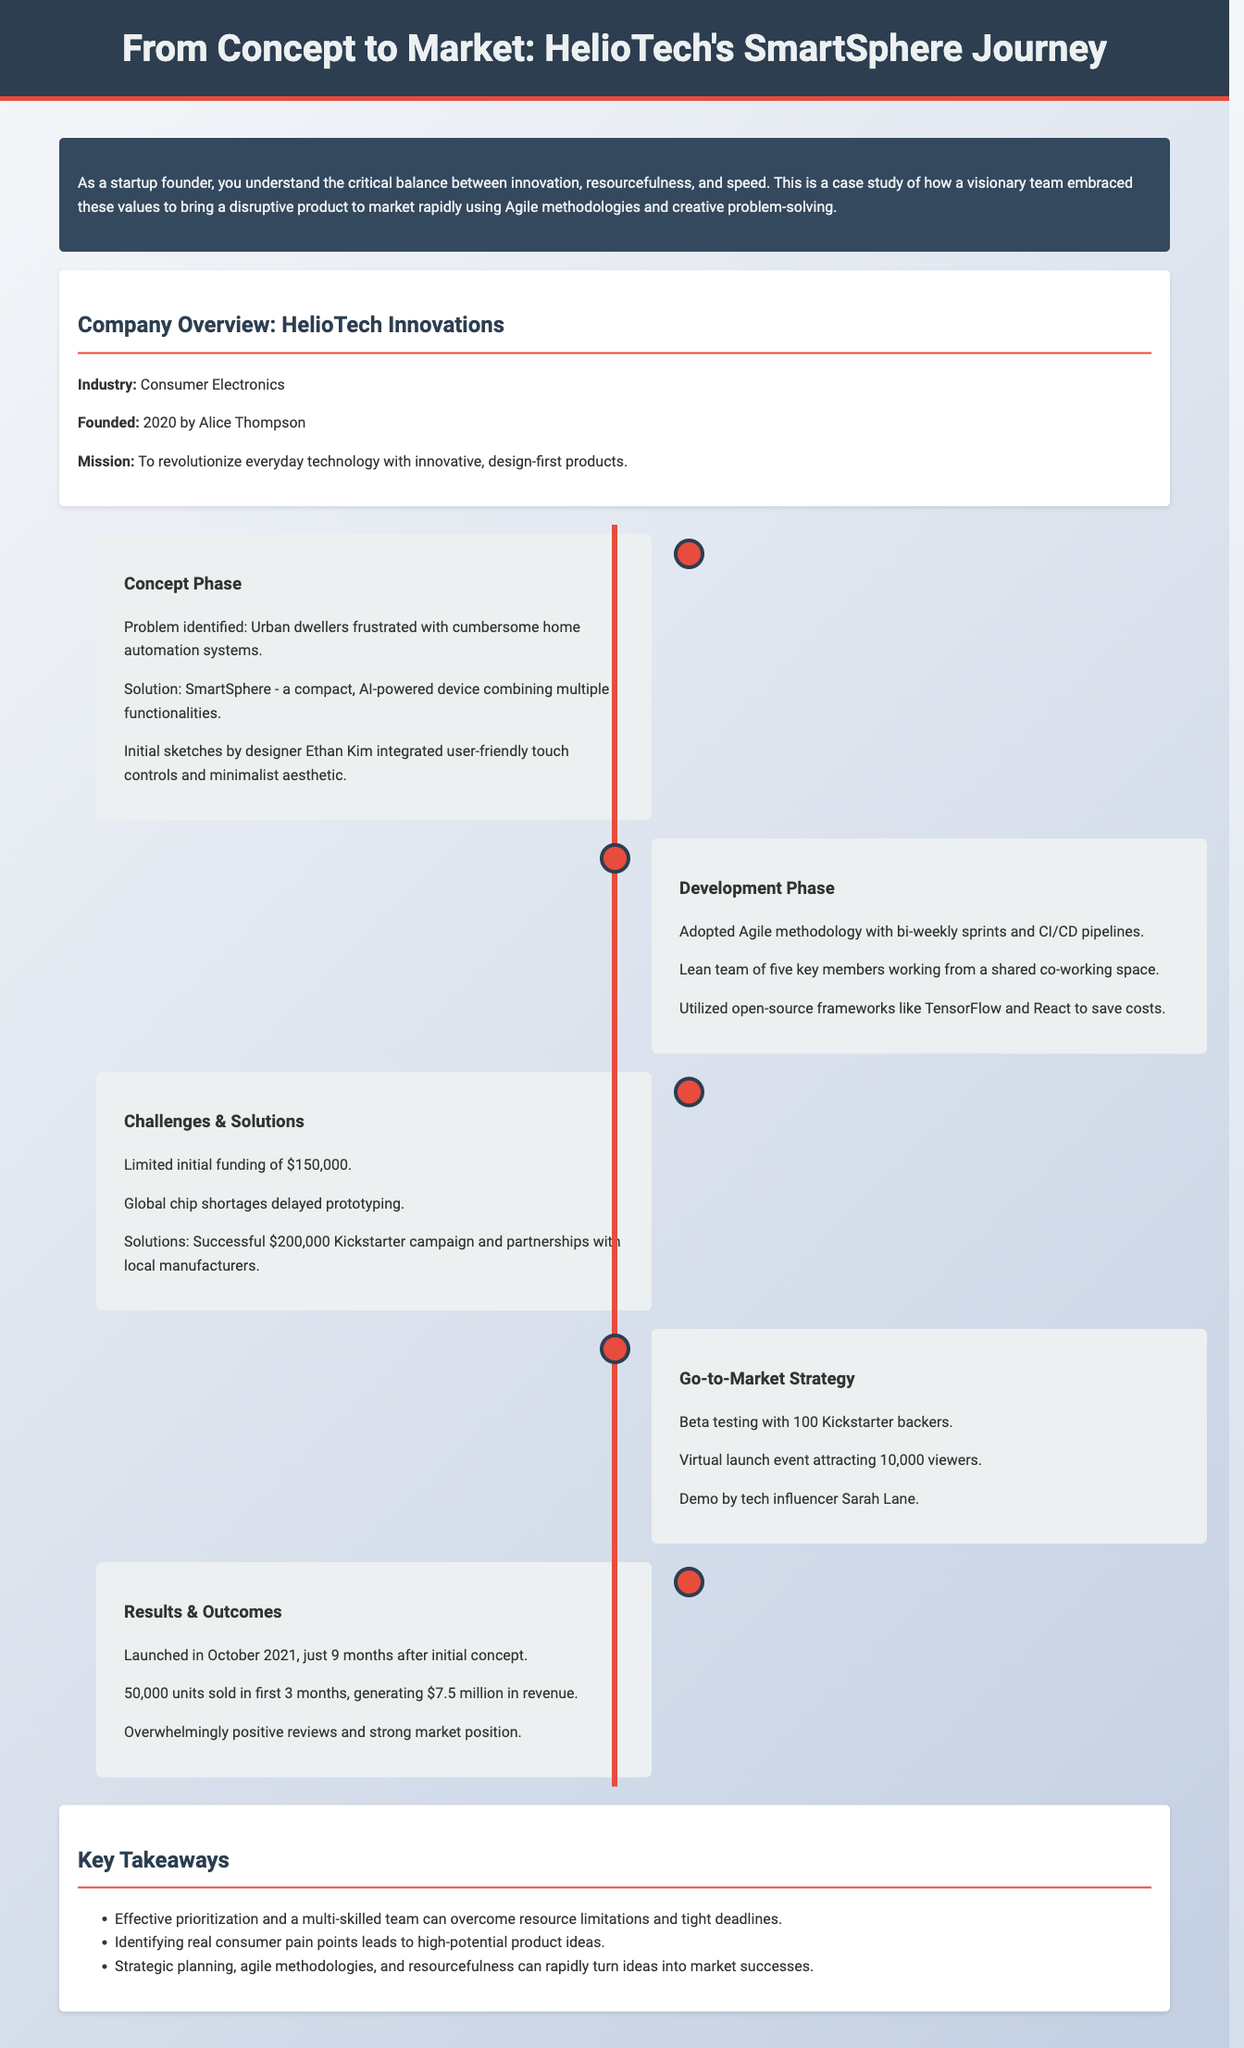what is the name of the company? The company featured in the case study is HelioTech Innovations.
Answer: HelioTech Innovations who founded HelioTech? The founder of HelioTech Innovations is Alice Thompson.
Answer: Alice Thompson what product did HelioTech launch? The product launched by HelioTech is SmartSphere.
Answer: SmartSphere how long did it take to launch SmartSphere? The product was launched just 9 months after the initial concept phase.
Answer: 9 months what was the initial funding amount? The initial funding for the project was $150,000.
Answer: $150,000 how many units were sold in the first 3 months? The total units sold within the first three months after launch were 50,000.
Answer: 50,000 what revenue was generated in the first 3 months? The revenue generated in the first three months was $7.5 million.
Answer: $7.5 million how many Kickstarter backers participated in beta testing? The beta testing involved 100 Kickstarter backers.
Answer: 100 what methodology did HelioTech adopt during development? The methodology adopted during the development phase was Agile.
Answer: Agile 